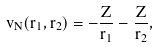<formula> <loc_0><loc_0><loc_500><loc_500>v _ { N } ( { r } _ { 1 } , { r } _ { 2 } ) = - \frac { Z } { r _ { 1 } } - \frac { Z } { r _ { 2 } } ,</formula> 